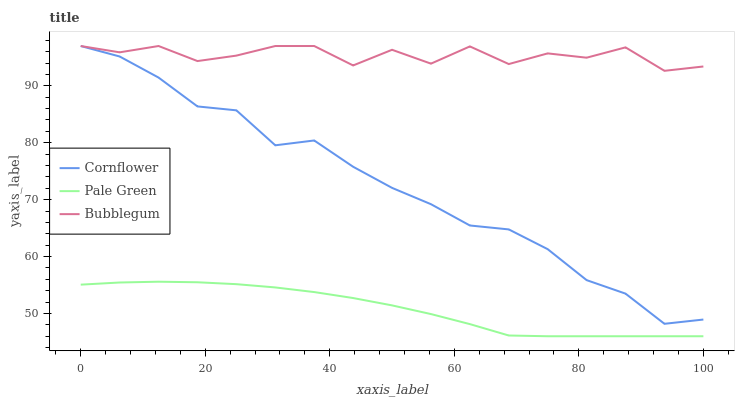Does Bubblegum have the minimum area under the curve?
Answer yes or no. No. Does Pale Green have the maximum area under the curve?
Answer yes or no. No. Is Bubblegum the smoothest?
Answer yes or no. No. Is Pale Green the roughest?
Answer yes or no. No. Does Bubblegum have the lowest value?
Answer yes or no. No. Does Pale Green have the highest value?
Answer yes or no. No. Is Pale Green less than Bubblegum?
Answer yes or no. Yes. Is Bubblegum greater than Pale Green?
Answer yes or no. Yes. Does Pale Green intersect Bubblegum?
Answer yes or no. No. 